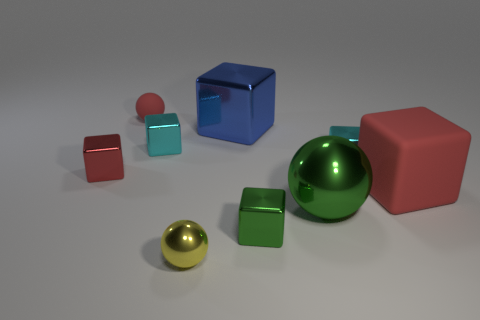There is a big shiny thing that is behind the shiny block that is on the right side of the big green metal thing; what color is it?
Your answer should be very brief. Blue. Does the matte object behind the large red matte block have the same color as the big sphere?
Keep it short and to the point. No. What material is the small cyan object that is to the right of the tiny yellow sphere?
Give a very brief answer. Metal. The red rubber block has what size?
Your answer should be compact. Large. Is the tiny object in front of the green shiny cube made of the same material as the small green object?
Offer a terse response. Yes. How many small brown matte spheres are there?
Your answer should be compact. 0. What number of things are either large metallic spheres or tiny red rubber objects?
Ensure brevity in your answer.  2. How many objects are to the left of the red thing that is to the right of the tiny sphere on the left side of the yellow sphere?
Keep it short and to the point. 8. Is there any other thing that is the same color as the small rubber ball?
Provide a succinct answer. Yes. Is the color of the cube that is in front of the big green object the same as the tiny metallic block on the right side of the green block?
Your answer should be compact. No. 